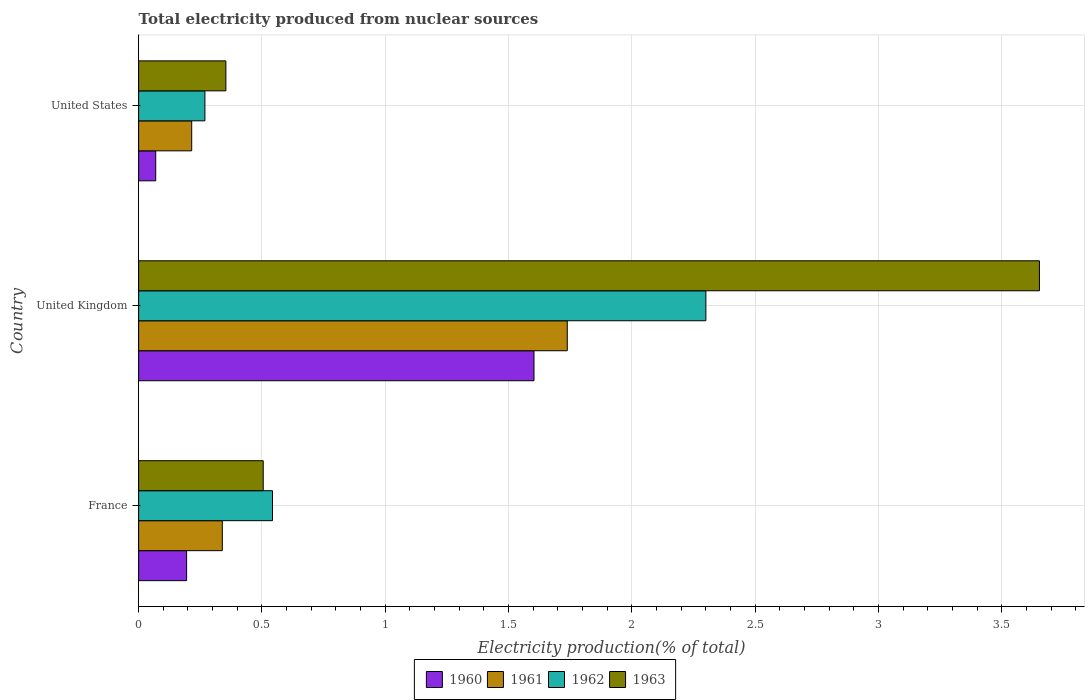How many groups of bars are there?
Offer a very short reply. 3. Are the number of bars on each tick of the Y-axis equal?
Your response must be concise. Yes. How many bars are there on the 3rd tick from the top?
Offer a very short reply. 4. How many bars are there on the 2nd tick from the bottom?
Ensure brevity in your answer.  4. What is the total electricity produced in 1960 in United States?
Make the answer very short. 0.07. Across all countries, what is the maximum total electricity produced in 1962?
Keep it short and to the point. 2.3. Across all countries, what is the minimum total electricity produced in 1962?
Offer a terse response. 0.27. In which country was the total electricity produced in 1963 minimum?
Your answer should be compact. United States. What is the total total electricity produced in 1963 in the graph?
Ensure brevity in your answer.  4.51. What is the difference between the total electricity produced in 1963 in France and that in United Kingdom?
Ensure brevity in your answer.  -3.15. What is the difference between the total electricity produced in 1960 in United States and the total electricity produced in 1961 in France?
Your answer should be very brief. -0.27. What is the average total electricity produced in 1960 per country?
Your answer should be compact. 0.62. What is the difference between the total electricity produced in 1960 and total electricity produced in 1962 in United States?
Your response must be concise. -0.2. In how many countries, is the total electricity produced in 1961 greater than 2.4 %?
Make the answer very short. 0. What is the ratio of the total electricity produced in 1963 in United Kingdom to that in United States?
Keep it short and to the point. 10.32. Is the total electricity produced in 1960 in United Kingdom less than that in United States?
Offer a terse response. No. Is the difference between the total electricity produced in 1960 in France and United Kingdom greater than the difference between the total electricity produced in 1962 in France and United Kingdom?
Your answer should be very brief. Yes. What is the difference between the highest and the second highest total electricity produced in 1962?
Keep it short and to the point. 1.76. What is the difference between the highest and the lowest total electricity produced in 1962?
Offer a very short reply. 2.03. In how many countries, is the total electricity produced in 1960 greater than the average total electricity produced in 1960 taken over all countries?
Provide a short and direct response. 1. Is it the case that in every country, the sum of the total electricity produced in 1962 and total electricity produced in 1960 is greater than the sum of total electricity produced in 1963 and total electricity produced in 1961?
Provide a succinct answer. No. What does the 3rd bar from the top in United States represents?
Ensure brevity in your answer.  1961. Are all the bars in the graph horizontal?
Keep it short and to the point. Yes. What is the difference between two consecutive major ticks on the X-axis?
Provide a short and direct response. 0.5. Are the values on the major ticks of X-axis written in scientific E-notation?
Provide a succinct answer. No. How are the legend labels stacked?
Make the answer very short. Horizontal. What is the title of the graph?
Make the answer very short. Total electricity produced from nuclear sources. Does "2004" appear as one of the legend labels in the graph?
Offer a very short reply. No. What is the label or title of the X-axis?
Your answer should be very brief. Electricity production(% of total). What is the label or title of the Y-axis?
Your answer should be compact. Country. What is the Electricity production(% of total) of 1960 in France?
Keep it short and to the point. 0.19. What is the Electricity production(% of total) of 1961 in France?
Your answer should be compact. 0.34. What is the Electricity production(% of total) in 1962 in France?
Your answer should be compact. 0.54. What is the Electricity production(% of total) of 1963 in France?
Give a very brief answer. 0.51. What is the Electricity production(% of total) in 1960 in United Kingdom?
Ensure brevity in your answer.  1.6. What is the Electricity production(% of total) of 1961 in United Kingdom?
Keep it short and to the point. 1.74. What is the Electricity production(% of total) of 1962 in United Kingdom?
Ensure brevity in your answer.  2.3. What is the Electricity production(% of total) of 1963 in United Kingdom?
Offer a terse response. 3.65. What is the Electricity production(% of total) in 1960 in United States?
Provide a succinct answer. 0.07. What is the Electricity production(% of total) in 1961 in United States?
Offer a terse response. 0.22. What is the Electricity production(% of total) in 1962 in United States?
Offer a very short reply. 0.27. What is the Electricity production(% of total) in 1963 in United States?
Make the answer very short. 0.35. Across all countries, what is the maximum Electricity production(% of total) in 1960?
Offer a very short reply. 1.6. Across all countries, what is the maximum Electricity production(% of total) in 1961?
Keep it short and to the point. 1.74. Across all countries, what is the maximum Electricity production(% of total) in 1962?
Offer a terse response. 2.3. Across all countries, what is the maximum Electricity production(% of total) in 1963?
Your response must be concise. 3.65. Across all countries, what is the minimum Electricity production(% of total) of 1960?
Your response must be concise. 0.07. Across all countries, what is the minimum Electricity production(% of total) of 1961?
Your answer should be compact. 0.22. Across all countries, what is the minimum Electricity production(% of total) of 1962?
Make the answer very short. 0.27. Across all countries, what is the minimum Electricity production(% of total) of 1963?
Your response must be concise. 0.35. What is the total Electricity production(% of total) in 1960 in the graph?
Your answer should be compact. 1.87. What is the total Electricity production(% of total) in 1961 in the graph?
Your response must be concise. 2.29. What is the total Electricity production(% of total) of 1962 in the graph?
Give a very brief answer. 3.11. What is the total Electricity production(% of total) in 1963 in the graph?
Offer a very short reply. 4.51. What is the difference between the Electricity production(% of total) in 1960 in France and that in United Kingdom?
Give a very brief answer. -1.41. What is the difference between the Electricity production(% of total) in 1961 in France and that in United Kingdom?
Your answer should be compact. -1.4. What is the difference between the Electricity production(% of total) of 1962 in France and that in United Kingdom?
Provide a succinct answer. -1.76. What is the difference between the Electricity production(% of total) of 1963 in France and that in United Kingdom?
Your answer should be compact. -3.15. What is the difference between the Electricity production(% of total) in 1960 in France and that in United States?
Offer a very short reply. 0.13. What is the difference between the Electricity production(% of total) in 1961 in France and that in United States?
Make the answer very short. 0.12. What is the difference between the Electricity production(% of total) in 1962 in France and that in United States?
Ensure brevity in your answer.  0.27. What is the difference between the Electricity production(% of total) in 1963 in France and that in United States?
Provide a succinct answer. 0.15. What is the difference between the Electricity production(% of total) in 1960 in United Kingdom and that in United States?
Make the answer very short. 1.53. What is the difference between the Electricity production(% of total) in 1961 in United Kingdom and that in United States?
Your answer should be very brief. 1.52. What is the difference between the Electricity production(% of total) in 1962 in United Kingdom and that in United States?
Provide a succinct answer. 2.03. What is the difference between the Electricity production(% of total) of 1963 in United Kingdom and that in United States?
Your response must be concise. 3.3. What is the difference between the Electricity production(% of total) in 1960 in France and the Electricity production(% of total) in 1961 in United Kingdom?
Make the answer very short. -1.54. What is the difference between the Electricity production(% of total) of 1960 in France and the Electricity production(% of total) of 1962 in United Kingdom?
Provide a short and direct response. -2.11. What is the difference between the Electricity production(% of total) in 1960 in France and the Electricity production(% of total) in 1963 in United Kingdom?
Your response must be concise. -3.46. What is the difference between the Electricity production(% of total) of 1961 in France and the Electricity production(% of total) of 1962 in United Kingdom?
Your answer should be compact. -1.96. What is the difference between the Electricity production(% of total) of 1961 in France and the Electricity production(% of total) of 1963 in United Kingdom?
Your response must be concise. -3.31. What is the difference between the Electricity production(% of total) in 1962 in France and the Electricity production(% of total) in 1963 in United Kingdom?
Offer a terse response. -3.11. What is the difference between the Electricity production(% of total) in 1960 in France and the Electricity production(% of total) in 1961 in United States?
Your answer should be very brief. -0.02. What is the difference between the Electricity production(% of total) in 1960 in France and the Electricity production(% of total) in 1962 in United States?
Make the answer very short. -0.07. What is the difference between the Electricity production(% of total) of 1960 in France and the Electricity production(% of total) of 1963 in United States?
Your answer should be compact. -0.16. What is the difference between the Electricity production(% of total) of 1961 in France and the Electricity production(% of total) of 1962 in United States?
Ensure brevity in your answer.  0.07. What is the difference between the Electricity production(% of total) in 1961 in France and the Electricity production(% of total) in 1963 in United States?
Offer a terse response. -0.01. What is the difference between the Electricity production(% of total) in 1962 in France and the Electricity production(% of total) in 1963 in United States?
Provide a succinct answer. 0.19. What is the difference between the Electricity production(% of total) in 1960 in United Kingdom and the Electricity production(% of total) in 1961 in United States?
Your response must be concise. 1.39. What is the difference between the Electricity production(% of total) of 1960 in United Kingdom and the Electricity production(% of total) of 1962 in United States?
Your answer should be compact. 1.33. What is the difference between the Electricity production(% of total) in 1960 in United Kingdom and the Electricity production(% of total) in 1963 in United States?
Offer a terse response. 1.25. What is the difference between the Electricity production(% of total) of 1961 in United Kingdom and the Electricity production(% of total) of 1962 in United States?
Give a very brief answer. 1.47. What is the difference between the Electricity production(% of total) of 1961 in United Kingdom and the Electricity production(% of total) of 1963 in United States?
Make the answer very short. 1.38. What is the difference between the Electricity production(% of total) in 1962 in United Kingdom and the Electricity production(% of total) in 1963 in United States?
Your answer should be compact. 1.95. What is the average Electricity production(% of total) in 1960 per country?
Provide a succinct answer. 0.62. What is the average Electricity production(% of total) in 1961 per country?
Your answer should be very brief. 0.76. What is the average Electricity production(% of total) in 1962 per country?
Keep it short and to the point. 1.04. What is the average Electricity production(% of total) of 1963 per country?
Your answer should be compact. 1.5. What is the difference between the Electricity production(% of total) of 1960 and Electricity production(% of total) of 1961 in France?
Offer a terse response. -0.14. What is the difference between the Electricity production(% of total) in 1960 and Electricity production(% of total) in 1962 in France?
Provide a short and direct response. -0.35. What is the difference between the Electricity production(% of total) in 1960 and Electricity production(% of total) in 1963 in France?
Provide a succinct answer. -0.31. What is the difference between the Electricity production(% of total) in 1961 and Electricity production(% of total) in 1962 in France?
Keep it short and to the point. -0.2. What is the difference between the Electricity production(% of total) in 1961 and Electricity production(% of total) in 1963 in France?
Offer a terse response. -0.17. What is the difference between the Electricity production(% of total) in 1962 and Electricity production(% of total) in 1963 in France?
Your response must be concise. 0.04. What is the difference between the Electricity production(% of total) of 1960 and Electricity production(% of total) of 1961 in United Kingdom?
Your answer should be very brief. -0.13. What is the difference between the Electricity production(% of total) of 1960 and Electricity production(% of total) of 1962 in United Kingdom?
Your answer should be very brief. -0.7. What is the difference between the Electricity production(% of total) of 1960 and Electricity production(% of total) of 1963 in United Kingdom?
Offer a very short reply. -2.05. What is the difference between the Electricity production(% of total) of 1961 and Electricity production(% of total) of 1962 in United Kingdom?
Make the answer very short. -0.56. What is the difference between the Electricity production(% of total) of 1961 and Electricity production(% of total) of 1963 in United Kingdom?
Provide a short and direct response. -1.91. What is the difference between the Electricity production(% of total) in 1962 and Electricity production(% of total) in 1963 in United Kingdom?
Provide a succinct answer. -1.35. What is the difference between the Electricity production(% of total) in 1960 and Electricity production(% of total) in 1961 in United States?
Provide a short and direct response. -0.15. What is the difference between the Electricity production(% of total) in 1960 and Electricity production(% of total) in 1962 in United States?
Your answer should be compact. -0.2. What is the difference between the Electricity production(% of total) in 1960 and Electricity production(% of total) in 1963 in United States?
Offer a very short reply. -0.28. What is the difference between the Electricity production(% of total) of 1961 and Electricity production(% of total) of 1962 in United States?
Your response must be concise. -0.05. What is the difference between the Electricity production(% of total) in 1961 and Electricity production(% of total) in 1963 in United States?
Give a very brief answer. -0.14. What is the difference between the Electricity production(% of total) in 1962 and Electricity production(% of total) in 1963 in United States?
Make the answer very short. -0.09. What is the ratio of the Electricity production(% of total) of 1960 in France to that in United Kingdom?
Make the answer very short. 0.12. What is the ratio of the Electricity production(% of total) in 1961 in France to that in United Kingdom?
Keep it short and to the point. 0.2. What is the ratio of the Electricity production(% of total) in 1962 in France to that in United Kingdom?
Provide a short and direct response. 0.24. What is the ratio of the Electricity production(% of total) in 1963 in France to that in United Kingdom?
Your answer should be compact. 0.14. What is the ratio of the Electricity production(% of total) of 1960 in France to that in United States?
Offer a terse response. 2.81. What is the ratio of the Electricity production(% of total) of 1961 in France to that in United States?
Offer a terse response. 1.58. What is the ratio of the Electricity production(% of total) in 1962 in France to that in United States?
Give a very brief answer. 2.02. What is the ratio of the Electricity production(% of total) of 1963 in France to that in United States?
Keep it short and to the point. 1.43. What is the ratio of the Electricity production(% of total) in 1960 in United Kingdom to that in United States?
Offer a terse response. 23.14. What is the ratio of the Electricity production(% of total) in 1961 in United Kingdom to that in United States?
Offer a terse response. 8.08. What is the ratio of the Electricity production(% of total) of 1962 in United Kingdom to that in United States?
Your answer should be compact. 8.56. What is the ratio of the Electricity production(% of total) of 1963 in United Kingdom to that in United States?
Your answer should be very brief. 10.32. What is the difference between the highest and the second highest Electricity production(% of total) of 1960?
Keep it short and to the point. 1.41. What is the difference between the highest and the second highest Electricity production(% of total) of 1961?
Offer a terse response. 1.4. What is the difference between the highest and the second highest Electricity production(% of total) in 1962?
Provide a short and direct response. 1.76. What is the difference between the highest and the second highest Electricity production(% of total) of 1963?
Keep it short and to the point. 3.15. What is the difference between the highest and the lowest Electricity production(% of total) in 1960?
Your answer should be very brief. 1.53. What is the difference between the highest and the lowest Electricity production(% of total) of 1961?
Your answer should be very brief. 1.52. What is the difference between the highest and the lowest Electricity production(% of total) in 1962?
Offer a terse response. 2.03. What is the difference between the highest and the lowest Electricity production(% of total) in 1963?
Provide a short and direct response. 3.3. 